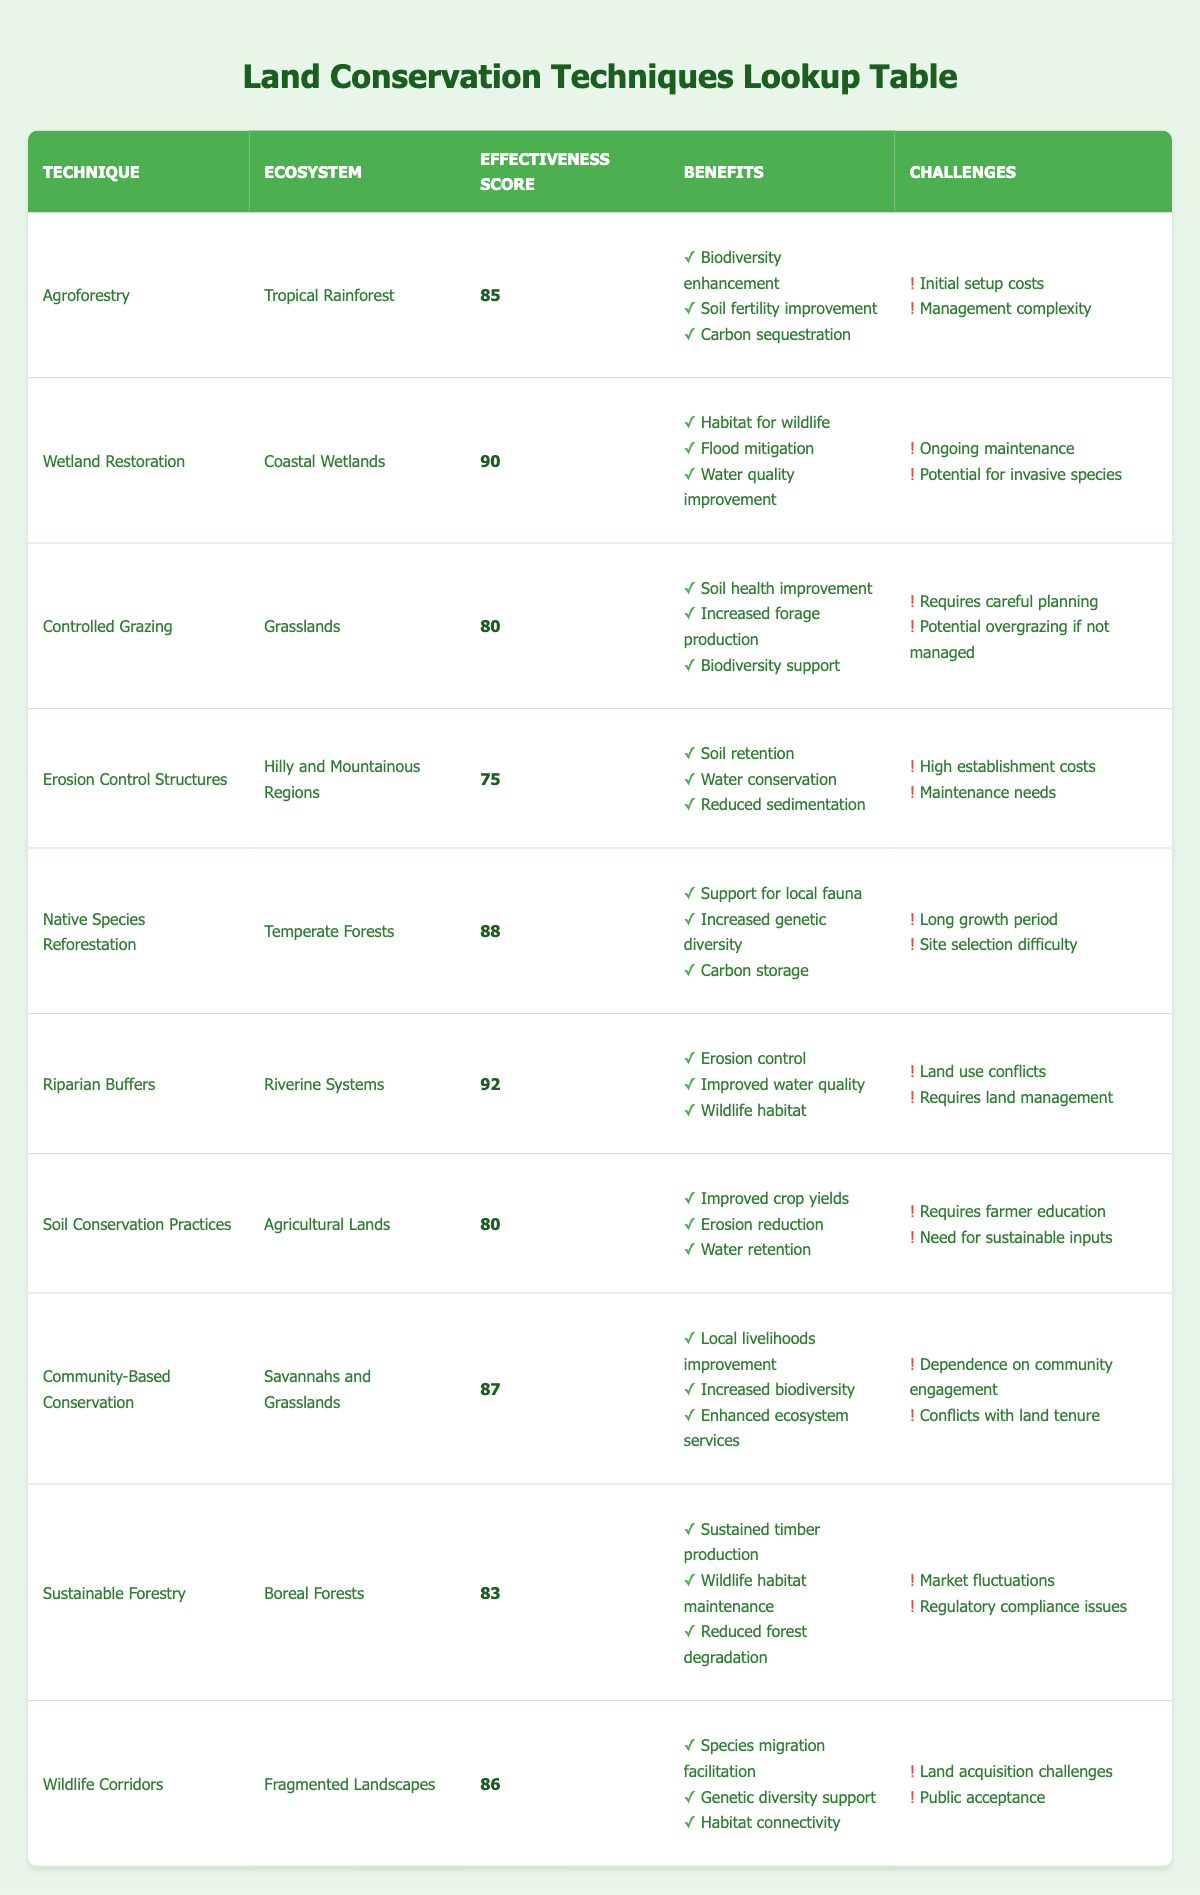What is the effectiveness score for Wetland Restoration? The effectiveness score for Wetland Restoration can be found directly in the table, where it lists the score as 90.
Answer: 90 Which technique has the highest effectiveness score? By reviewing the effectiveness scores in the table, the technique with the highest score is Riparian Buffers, which has a score of 92.
Answer: Riparian Buffers What are the benefits of Native Species Reforestation? The benefits for Native Species Reforestation can be directly extracted from the corresponding row in the table, which lists them as support for local fauna, increased genetic diversity, and carbon storage.
Answer: Support for local fauna, increased genetic diversity, carbon storage Is Soil Conservation Practices effective in improving water retention? Yes, the table states that one of the benefits of Soil Conservation Practices is water retention, confirming its effectiveness in that area.
Answer: Yes What is the average effectiveness score for the conservation techniques listed? To find the average, first, sum the effectiveness scores: 85 + 90 + 80 + 75 + 88 + 92 + 80 + 87 + 83 + 86 =  836. Then divide by the total number of techniques, which is 10: 836 / 10 = 83.6.
Answer: 83.6 What challenges do Riparian Buffers face compared to Wetland Restoration? For Riparian Buffers, the challenges listed are land use conflicts and requires land management, while for Wetland Restoration, the challenges are ongoing maintenance and the potential for invasive species. This comparison shows that each has different specific challenges in their implementation.
Answer: Land use conflicts and requires land management vs ongoing maintenance and potential for invasive species Do Controlled Grazing and Soil Conservation Practices provide similar benefits? Both techniques provide benefits that include improved soil health and water retention. However, while Controlled Grazing focuses more on forage production and biodiversity support, Soil Conservation Practices specifically improve crop yields. Thus, while they share some benefits, they also serve slightly different purposes.
Answer: No, they have some overlapping benefits but also distinct foci What is the combined effectiveness score of the top three techniques? The top three techniques based on effectiveness scores are Riparian Buffers (92), Wetland Restoration (90), and Native Species Reforestation (88). Summing these gives: 92 + 90 + 88 = 270.
Answer: 270 Which ecosystem benefits most from Community-Based Conservation? The table shows that Community-Based Conservation is applied in Savannahs and Grasslands, indicating that these ecosystems benefit from this technique specifically.
Answer: Savannahs and Grasslands 